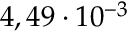<formula> <loc_0><loc_0><loc_500><loc_500>4 , 4 9 \cdot 1 0 ^ { - 3 }</formula> 